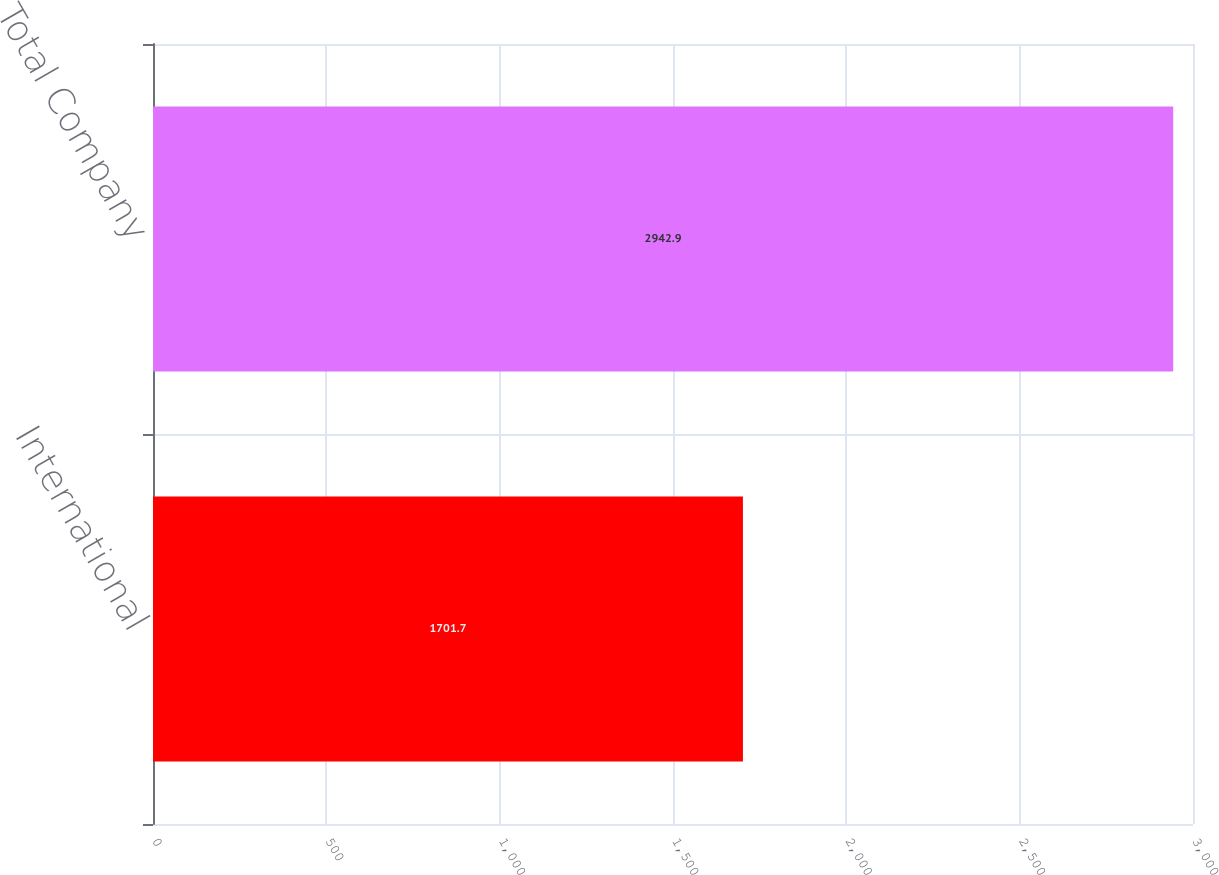Convert chart to OTSL. <chart><loc_0><loc_0><loc_500><loc_500><bar_chart><fcel>International<fcel>Total Company<nl><fcel>1701.7<fcel>2942.9<nl></chart> 